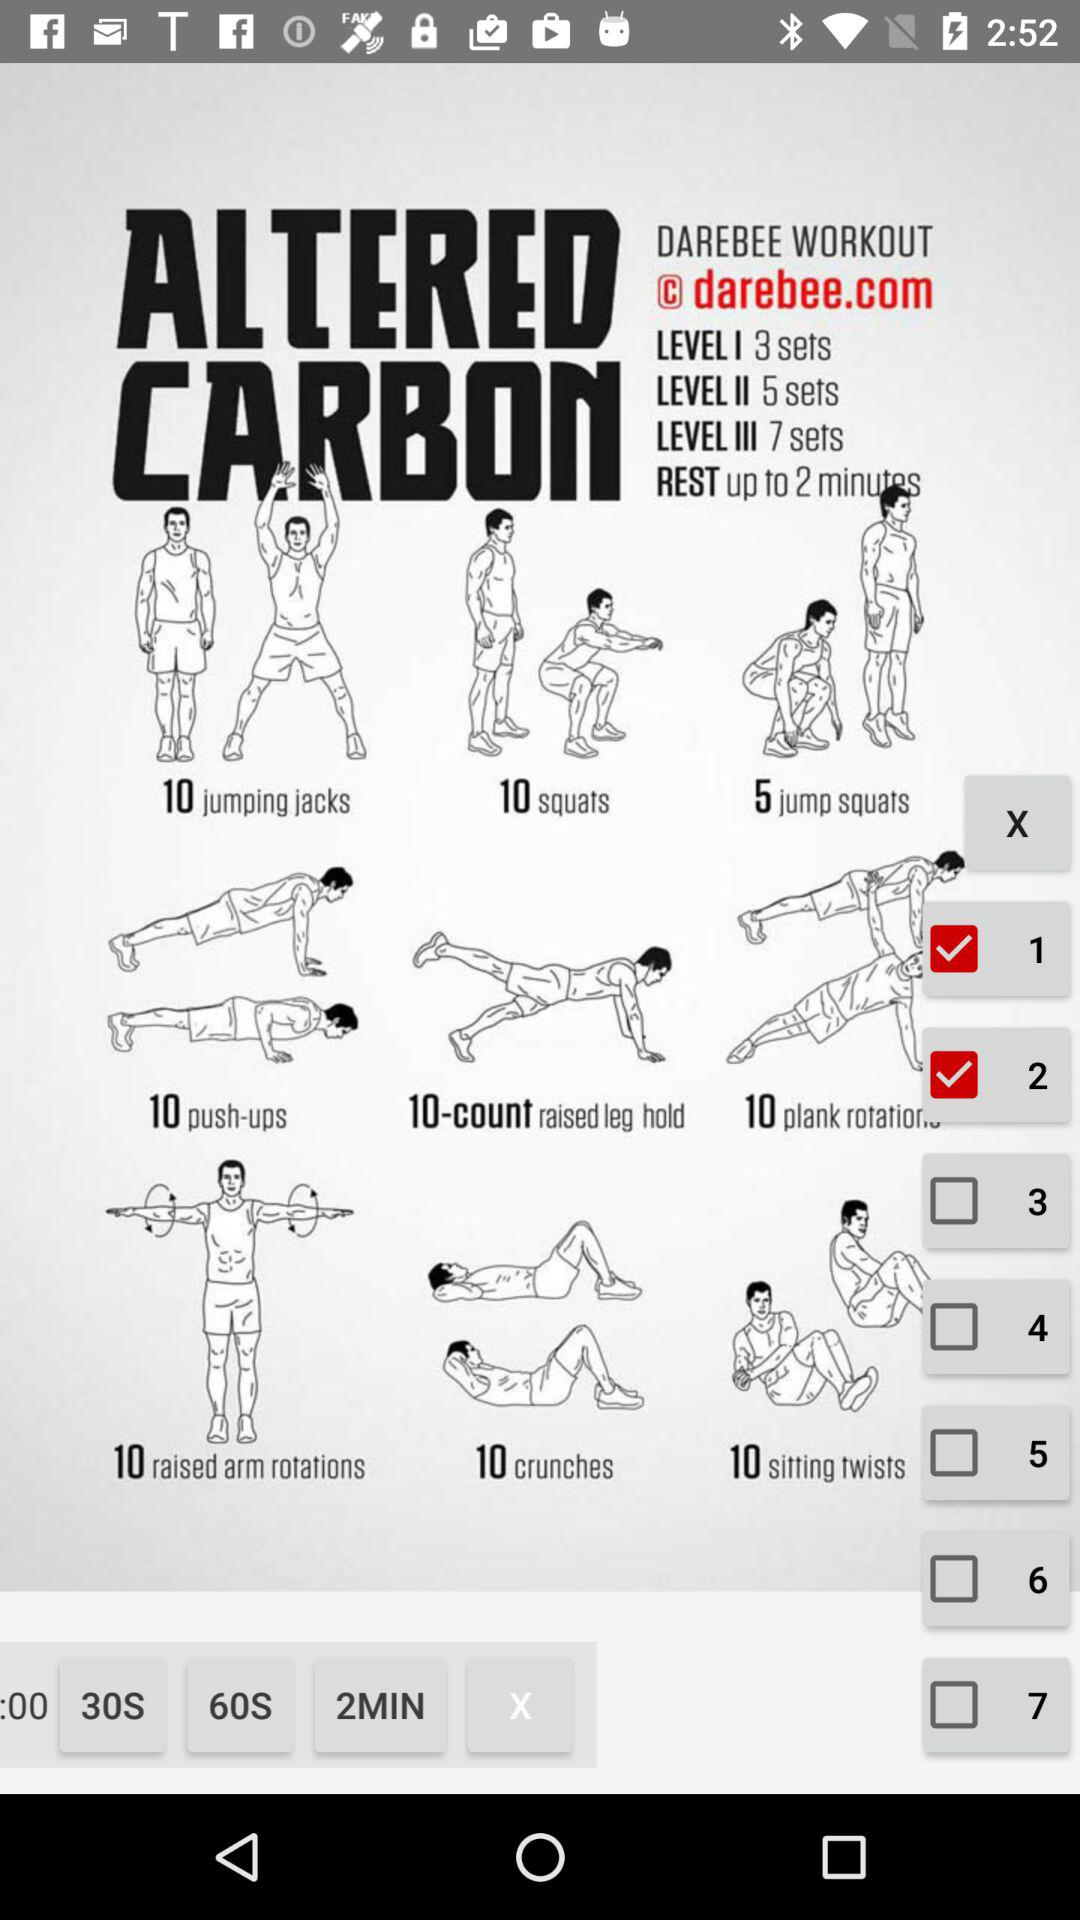What is the time duration for rest? The time duration for rest is up to 2 minutes. 